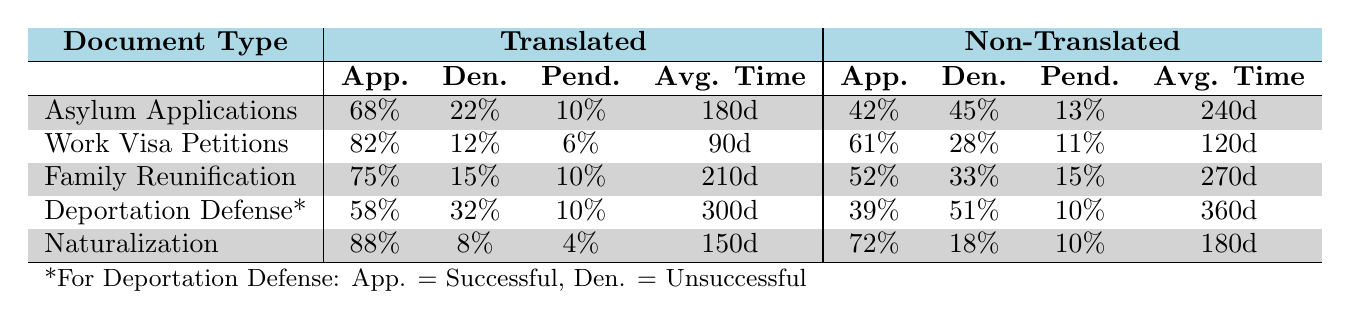What is the approval rate for translated Asylum Applications? The approval rate for translated Asylum Applications can be found under the Translated column next to Asylum Applications. It states 68 approved out of 100 total responses (68% approval).
Answer: 68% What is the average processing time for Work Visa Petitions that were not translated? The average processing time for non-translated Work Visa Petitions is listed as 120 days in the Non-Translated column next to Work Visa Petitions.
Answer: 120 days What is the difference in approval rates between translated and non-translated Family Reunification Applications? The approval rate for translated Family Reunification Applications is 75%, while the non-translated approval rate is 52%. The difference is 75% - 52% = 23%.
Answer: 23% Are Deportation Defense cases more successful when documents are translated? The successful rate for translated Deportation Defense cases is 58%, while it is 39% for non-translated cases. Since 58% is greater than 39%, it can be concluded that translation does result in more successful cases.
Answer: Yes How many more denied Asylum Applications are there for non-translated documents compared to translated ones? For translated Asylum Applications, there are 22 denied cases, while for non-translated, there are 45 denied cases. The difference is 45 - 22 = 23.
Answer: 23 What is the overall trend in approval rates for translated versus non-translated Naturalization Applications? The approval rate for translated Naturalization Applications is 88%, while it is 72% for non-translated. This indicates a higher approval rate for translated documents.
Answer: Higher approval rate for translated documents What is the average case duration for translated Deportation Defense cases compared to non-translated ones? The average case duration for translated Deportation Defense cases is 300 days, while non-translated is 360 days. The average duration for translated is shorter by 360 - 300 = 60 days.
Answer: 60 days Which document type has the highest approval rate for non-translated documents? From the table, the document type with the highest approval rate for non-translated documents is Work Visa Petitions with an approval rate of 61%.
Answer: Work Visa Petitions What percentage of cases are translated into Spanish? The table lists Spanish as the top language translated with a percentage of 42% of all cases.
Answer: 42% Is the average processing time longer for translated or non-translated Family Reunification Applications? The average processing time for translated Family Reunification Applications is 210 days, whereas non-translated takes 270 days. Since 270 is larger than 210, non-translated applications take longer.
Answer: Non-translated applications take longer How does the pending percentage for translated and non-translated Work Visa Petitions compare? The pending percentage for translated Work Visa Petitions is 6%, while for non-translated it is 11%. To compare, non-translated has a higher pending percentage by 11% - 6% = 5%.
Answer: Non-translated has a higher pending percentage by 5% 